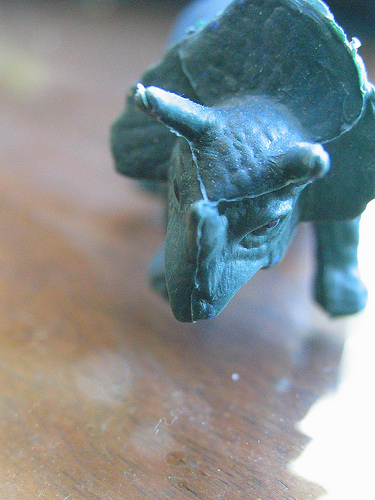<image>
Can you confirm if the dinosaur is on the wood? Yes. Looking at the image, I can see the dinosaur is positioned on top of the wood, with the wood providing support. 